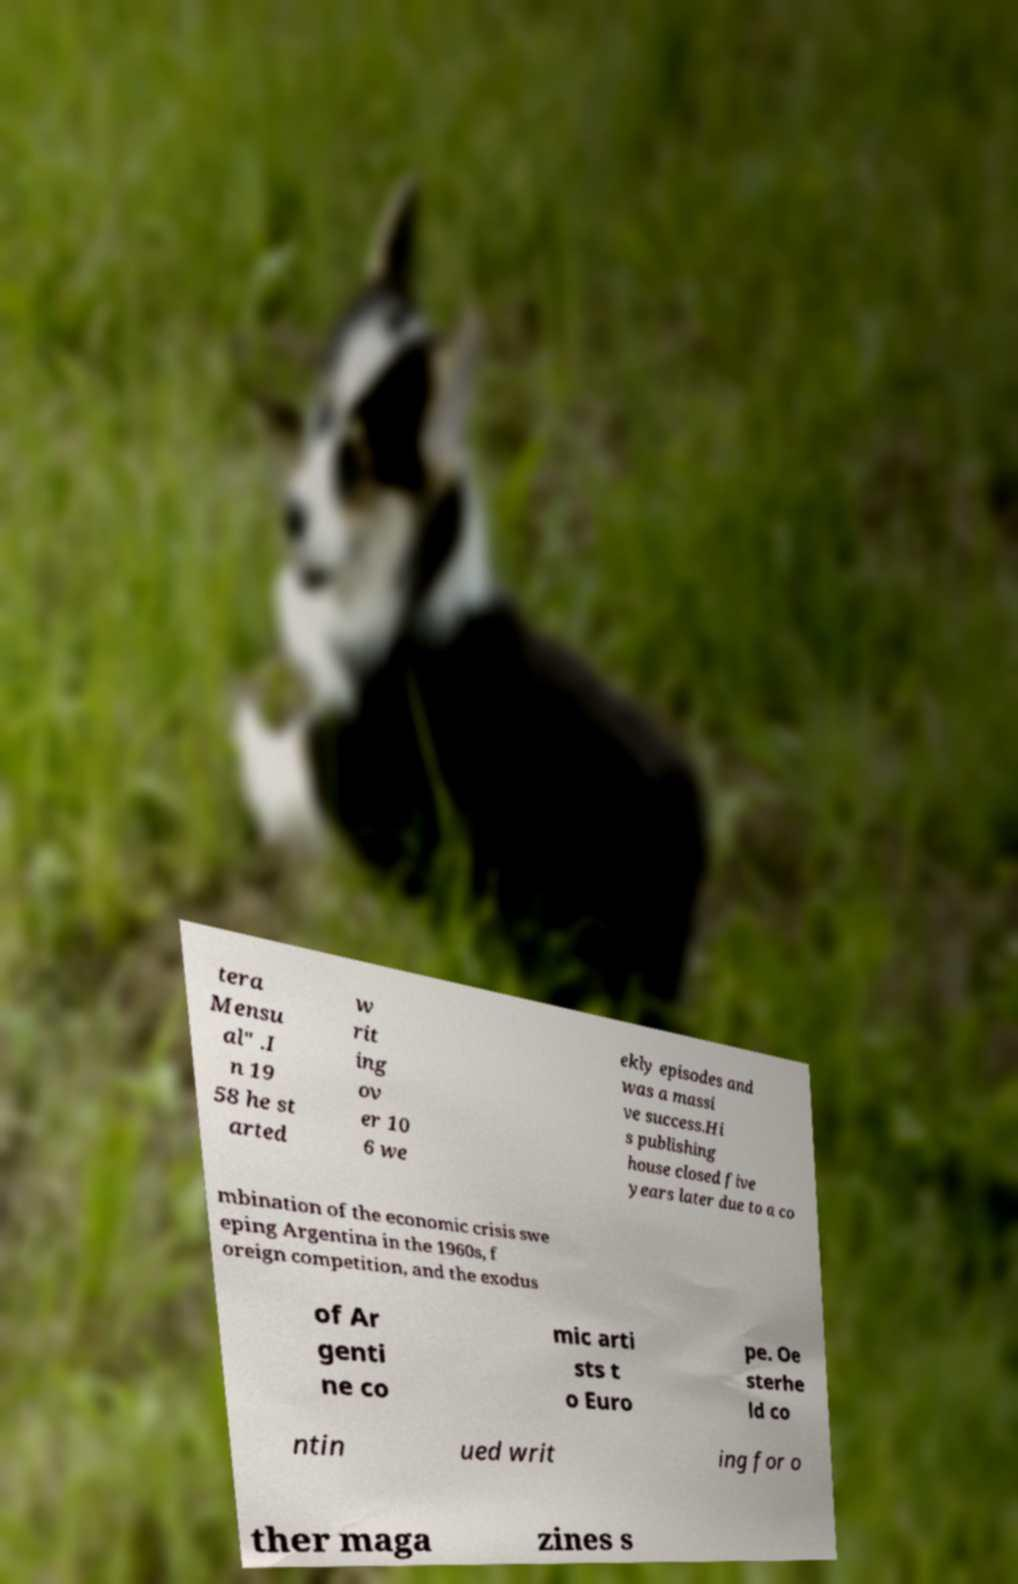I need the written content from this picture converted into text. Can you do that? tera Mensu al" .I n 19 58 he st arted w rit ing ov er 10 6 we ekly episodes and was a massi ve success.Hi s publishing house closed five years later due to a co mbination of the economic crisis swe eping Argentina in the 1960s, f oreign competition, and the exodus of Ar genti ne co mic arti sts t o Euro pe. Oe sterhe ld co ntin ued writ ing for o ther maga zines s 